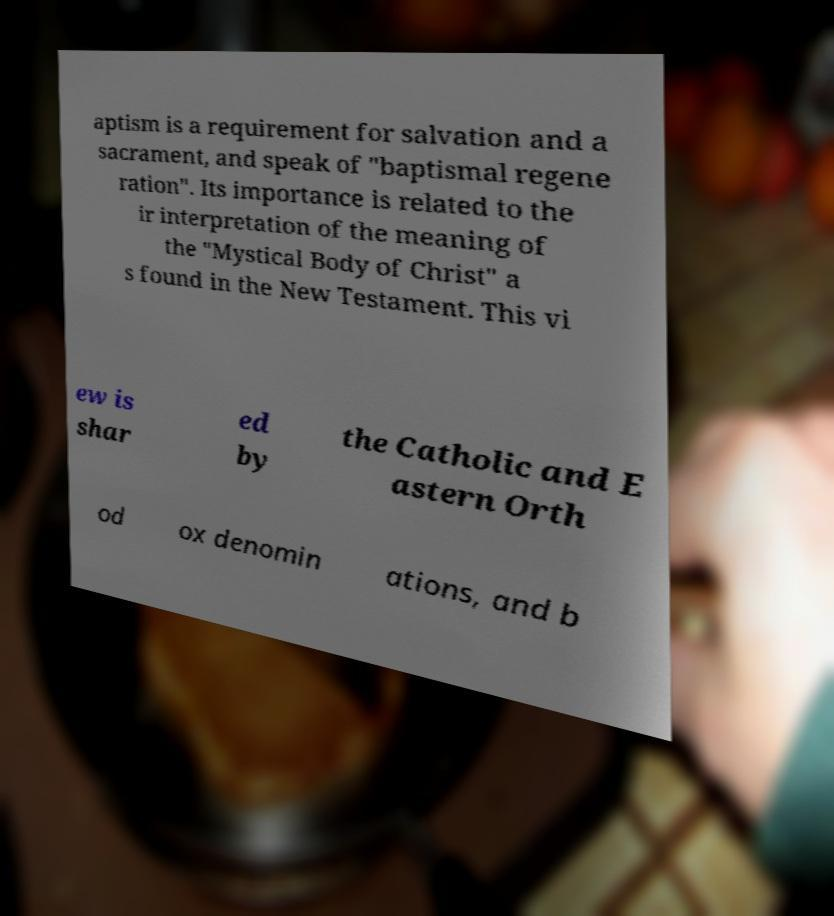Please identify and transcribe the text found in this image. aptism is a requirement for salvation and a sacrament, and speak of "baptismal regene ration". Its importance is related to the ir interpretation of the meaning of the "Mystical Body of Christ" a s found in the New Testament. This vi ew is shar ed by the Catholic and E astern Orth od ox denomin ations, and b 